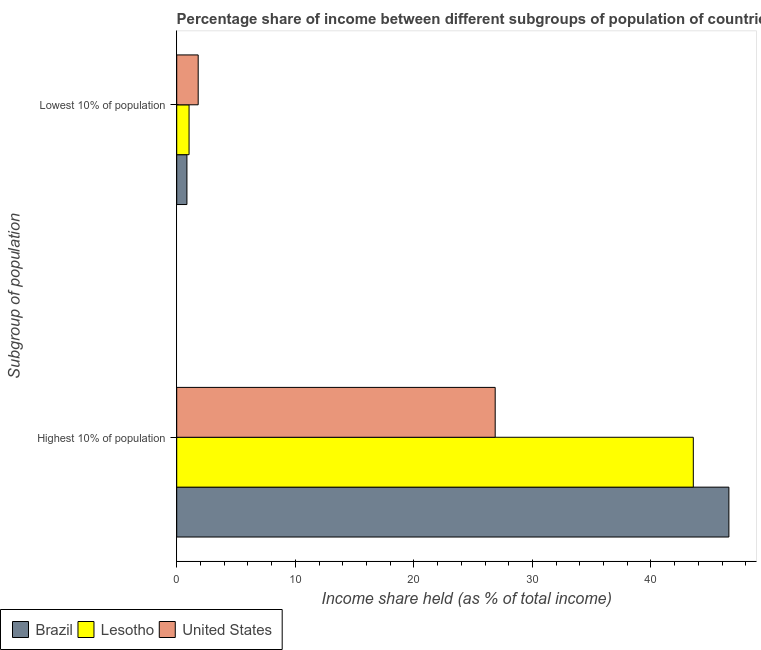How many groups of bars are there?
Offer a terse response. 2. Are the number of bars per tick equal to the number of legend labels?
Keep it short and to the point. Yes. Are the number of bars on each tick of the Y-axis equal?
Give a very brief answer. Yes. How many bars are there on the 2nd tick from the top?
Provide a short and direct response. 3. How many bars are there on the 1st tick from the bottom?
Your answer should be very brief. 3. What is the label of the 1st group of bars from the top?
Make the answer very short. Lowest 10% of population. What is the income share held by highest 10% of the population in United States?
Ensure brevity in your answer.  26.86. Across all countries, what is the maximum income share held by lowest 10% of the population?
Provide a short and direct response. 1.81. Across all countries, what is the minimum income share held by highest 10% of the population?
Offer a terse response. 26.86. In which country was the income share held by lowest 10% of the population minimum?
Give a very brief answer. Brazil. What is the total income share held by highest 10% of the population in the graph?
Your response must be concise. 117. What is the difference between the income share held by highest 10% of the population in Brazil and that in United States?
Provide a short and direct response. 19.71. What is the difference between the income share held by highest 10% of the population in Brazil and the income share held by lowest 10% of the population in Lesotho?
Your response must be concise. 45.53. What is the difference between the income share held by lowest 10% of the population and income share held by highest 10% of the population in Lesotho?
Offer a very short reply. -42.53. In how many countries, is the income share held by lowest 10% of the population greater than 32 %?
Your response must be concise. 0. What is the ratio of the income share held by lowest 10% of the population in Lesotho to that in Brazil?
Keep it short and to the point. 1.21. Is the income share held by lowest 10% of the population in United States less than that in Lesotho?
Make the answer very short. No. In how many countries, is the income share held by highest 10% of the population greater than the average income share held by highest 10% of the population taken over all countries?
Offer a very short reply. 2. What does the 3rd bar from the bottom in Lowest 10% of population represents?
Ensure brevity in your answer.  United States. How many bars are there?
Your answer should be very brief. 6. Are all the bars in the graph horizontal?
Provide a succinct answer. Yes. What is the difference between two consecutive major ticks on the X-axis?
Your response must be concise. 10. Does the graph contain any zero values?
Your answer should be compact. No. How many legend labels are there?
Provide a short and direct response. 3. What is the title of the graph?
Give a very brief answer. Percentage share of income between different subgroups of population of countries. Does "Dominica" appear as one of the legend labels in the graph?
Make the answer very short. No. What is the label or title of the X-axis?
Ensure brevity in your answer.  Income share held (as % of total income). What is the label or title of the Y-axis?
Provide a succinct answer. Subgroup of population. What is the Income share held (as % of total income) of Brazil in Highest 10% of population?
Ensure brevity in your answer.  46.57. What is the Income share held (as % of total income) in Lesotho in Highest 10% of population?
Offer a terse response. 43.57. What is the Income share held (as % of total income) in United States in Highest 10% of population?
Provide a succinct answer. 26.86. What is the Income share held (as % of total income) of Brazil in Lowest 10% of population?
Give a very brief answer. 0.86. What is the Income share held (as % of total income) in Lesotho in Lowest 10% of population?
Provide a short and direct response. 1.04. What is the Income share held (as % of total income) in United States in Lowest 10% of population?
Make the answer very short. 1.81. Across all Subgroup of population, what is the maximum Income share held (as % of total income) in Brazil?
Make the answer very short. 46.57. Across all Subgroup of population, what is the maximum Income share held (as % of total income) in Lesotho?
Provide a short and direct response. 43.57. Across all Subgroup of population, what is the maximum Income share held (as % of total income) in United States?
Keep it short and to the point. 26.86. Across all Subgroup of population, what is the minimum Income share held (as % of total income) of Brazil?
Ensure brevity in your answer.  0.86. Across all Subgroup of population, what is the minimum Income share held (as % of total income) of United States?
Provide a short and direct response. 1.81. What is the total Income share held (as % of total income) in Brazil in the graph?
Your answer should be very brief. 47.43. What is the total Income share held (as % of total income) of Lesotho in the graph?
Offer a very short reply. 44.61. What is the total Income share held (as % of total income) of United States in the graph?
Your answer should be compact. 28.67. What is the difference between the Income share held (as % of total income) in Brazil in Highest 10% of population and that in Lowest 10% of population?
Offer a very short reply. 45.71. What is the difference between the Income share held (as % of total income) of Lesotho in Highest 10% of population and that in Lowest 10% of population?
Ensure brevity in your answer.  42.53. What is the difference between the Income share held (as % of total income) in United States in Highest 10% of population and that in Lowest 10% of population?
Give a very brief answer. 25.05. What is the difference between the Income share held (as % of total income) in Brazil in Highest 10% of population and the Income share held (as % of total income) in Lesotho in Lowest 10% of population?
Your response must be concise. 45.53. What is the difference between the Income share held (as % of total income) of Brazil in Highest 10% of population and the Income share held (as % of total income) of United States in Lowest 10% of population?
Ensure brevity in your answer.  44.76. What is the difference between the Income share held (as % of total income) of Lesotho in Highest 10% of population and the Income share held (as % of total income) of United States in Lowest 10% of population?
Offer a very short reply. 41.76. What is the average Income share held (as % of total income) of Brazil per Subgroup of population?
Your answer should be compact. 23.71. What is the average Income share held (as % of total income) in Lesotho per Subgroup of population?
Provide a succinct answer. 22.3. What is the average Income share held (as % of total income) of United States per Subgroup of population?
Offer a terse response. 14.34. What is the difference between the Income share held (as % of total income) in Brazil and Income share held (as % of total income) in United States in Highest 10% of population?
Give a very brief answer. 19.71. What is the difference between the Income share held (as % of total income) in Lesotho and Income share held (as % of total income) in United States in Highest 10% of population?
Your answer should be very brief. 16.71. What is the difference between the Income share held (as % of total income) of Brazil and Income share held (as % of total income) of Lesotho in Lowest 10% of population?
Your response must be concise. -0.18. What is the difference between the Income share held (as % of total income) in Brazil and Income share held (as % of total income) in United States in Lowest 10% of population?
Your response must be concise. -0.95. What is the difference between the Income share held (as % of total income) in Lesotho and Income share held (as % of total income) in United States in Lowest 10% of population?
Ensure brevity in your answer.  -0.77. What is the ratio of the Income share held (as % of total income) of Brazil in Highest 10% of population to that in Lowest 10% of population?
Offer a very short reply. 54.15. What is the ratio of the Income share held (as % of total income) in Lesotho in Highest 10% of population to that in Lowest 10% of population?
Ensure brevity in your answer.  41.89. What is the ratio of the Income share held (as % of total income) of United States in Highest 10% of population to that in Lowest 10% of population?
Keep it short and to the point. 14.84. What is the difference between the highest and the second highest Income share held (as % of total income) of Brazil?
Give a very brief answer. 45.71. What is the difference between the highest and the second highest Income share held (as % of total income) of Lesotho?
Keep it short and to the point. 42.53. What is the difference between the highest and the second highest Income share held (as % of total income) of United States?
Your answer should be very brief. 25.05. What is the difference between the highest and the lowest Income share held (as % of total income) in Brazil?
Give a very brief answer. 45.71. What is the difference between the highest and the lowest Income share held (as % of total income) in Lesotho?
Offer a very short reply. 42.53. What is the difference between the highest and the lowest Income share held (as % of total income) in United States?
Ensure brevity in your answer.  25.05. 